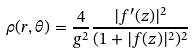<formula> <loc_0><loc_0><loc_500><loc_500>\rho ( r , \theta ) = \frac { 4 } { g ^ { 2 } } \frac { | f ^ { \prime } ( z ) | ^ { 2 } } { ( 1 + | f ( z ) | ^ { 2 } ) ^ { 2 } }</formula> 